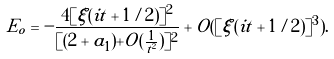Convert formula to latex. <formula><loc_0><loc_0><loc_500><loc_500>E _ { o } = - \frac { 4 [ \xi ( i t + 1 / 2 ) ] ^ { 2 } } { [ ( 2 + a _ { 1 } ) + O ( \frac { 1 } { t ^ { 2 } } ) ] ^ { 2 } } + O ( [ \xi ( i t + 1 / 2 ) ] ^ { 3 } ) .</formula> 